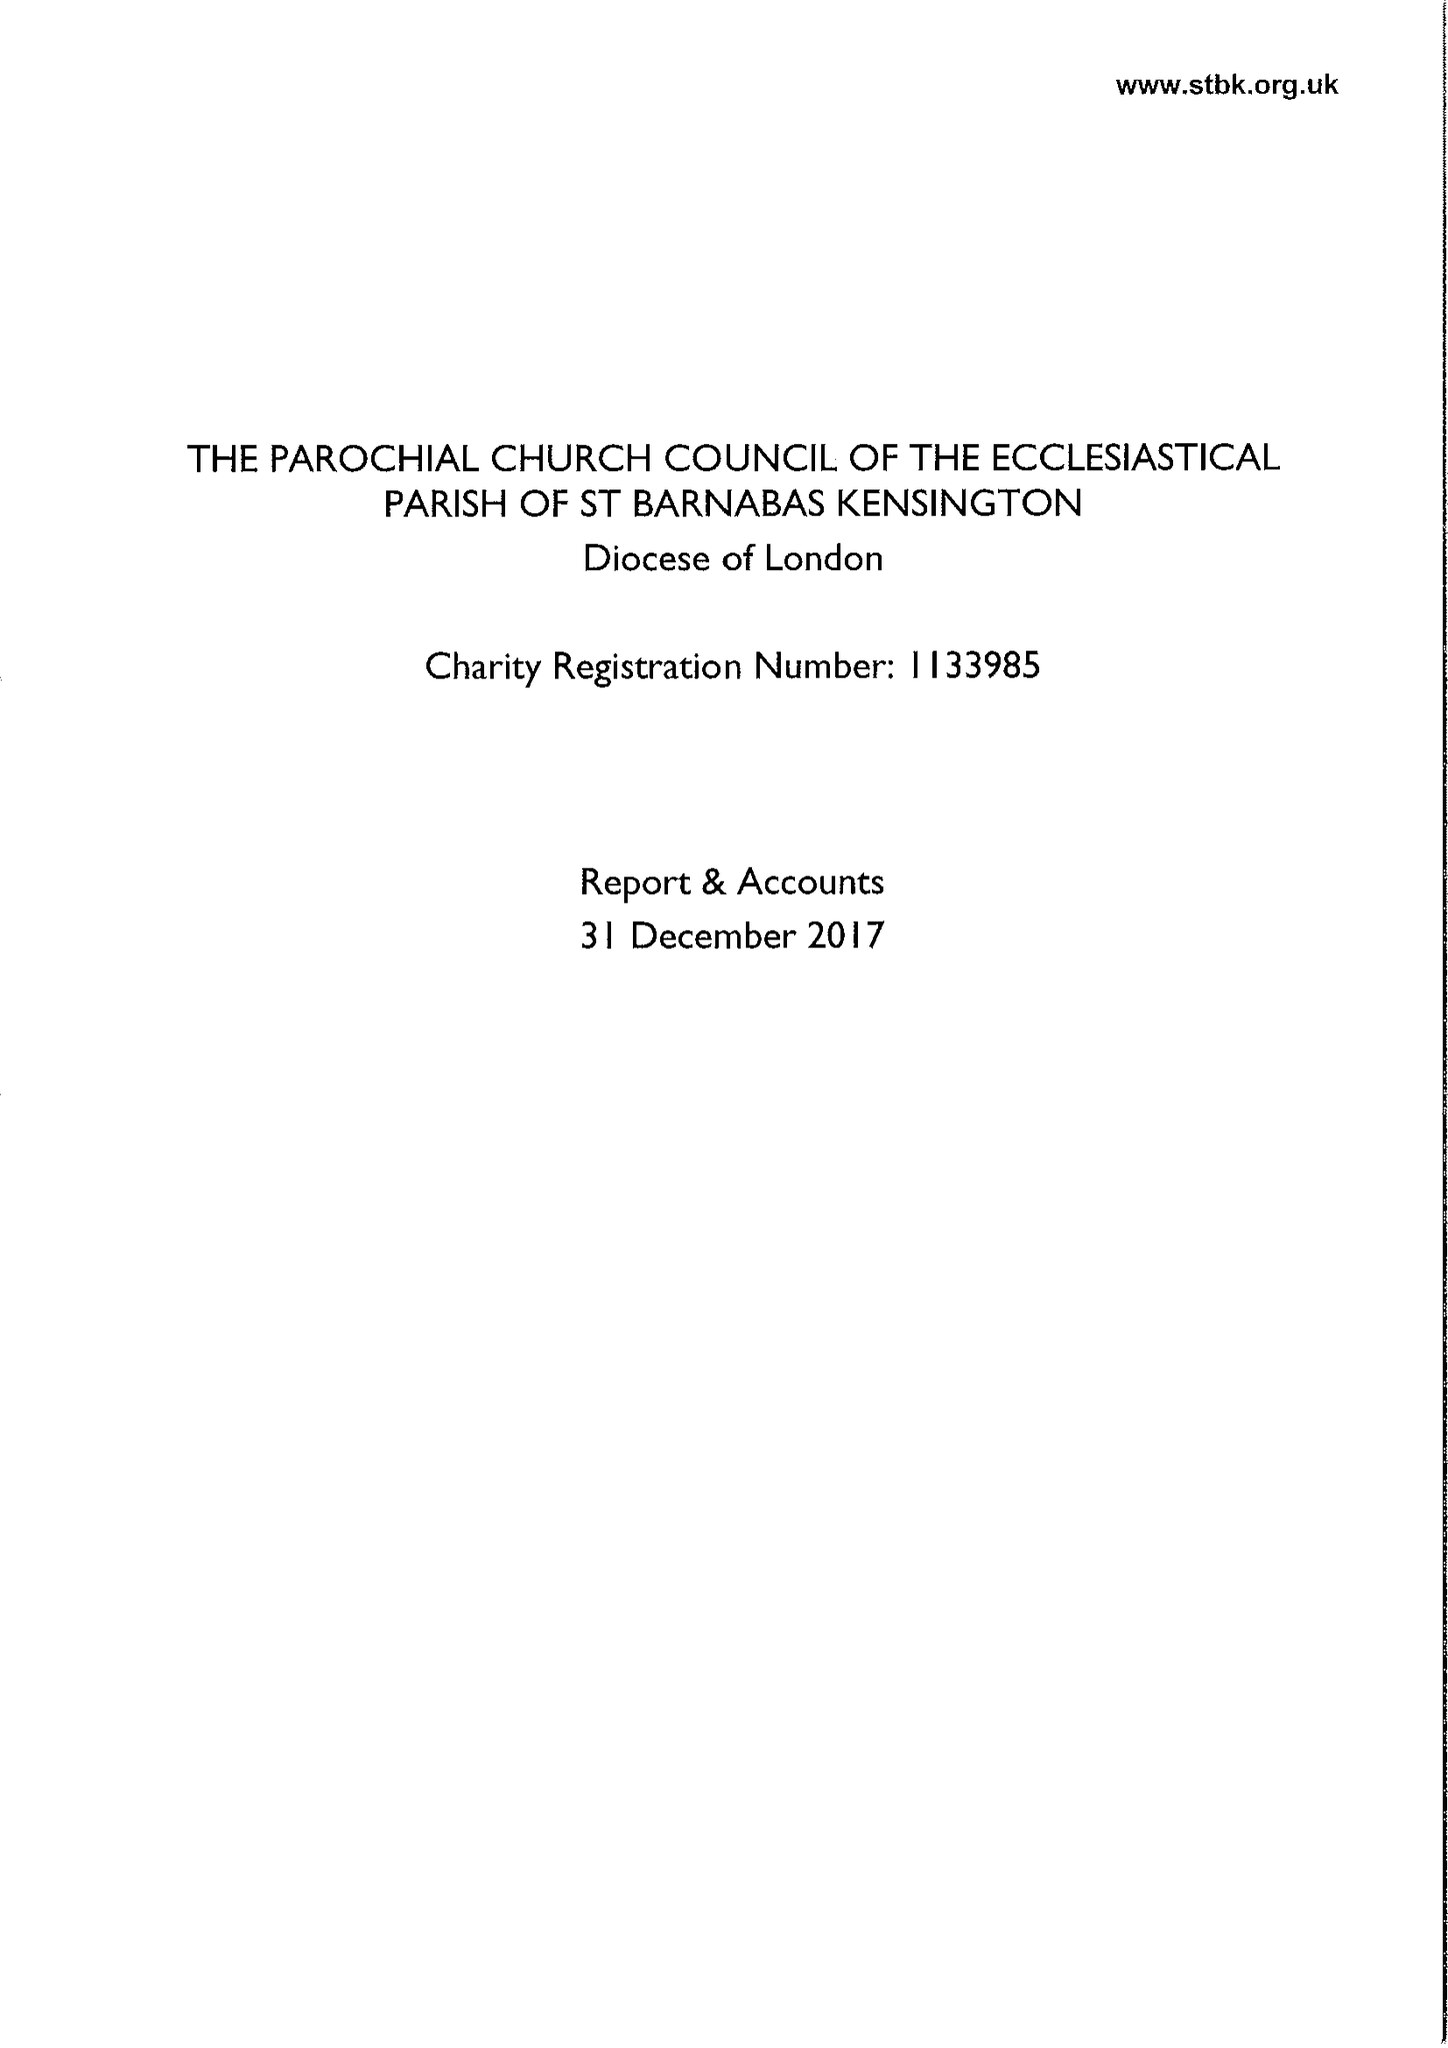What is the value for the address__postcode?
Answer the question using a single word or phrase. W14 8LH 